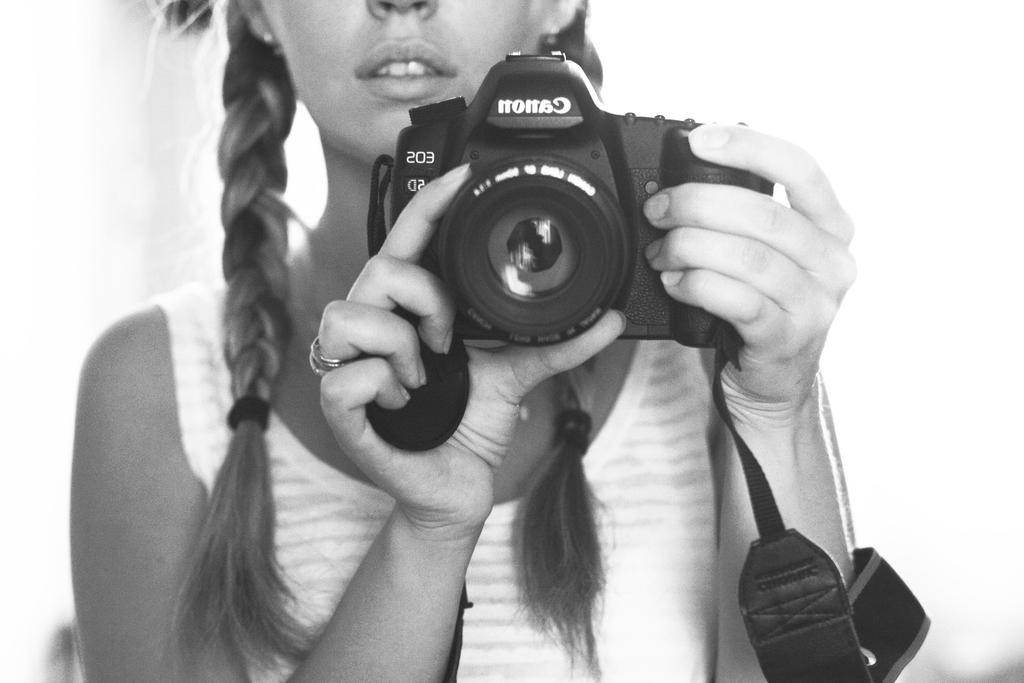How would you summarize this image in a sentence or two? In this picture we can see woman holding camera with her hands and she wore white color T-Shirt. 